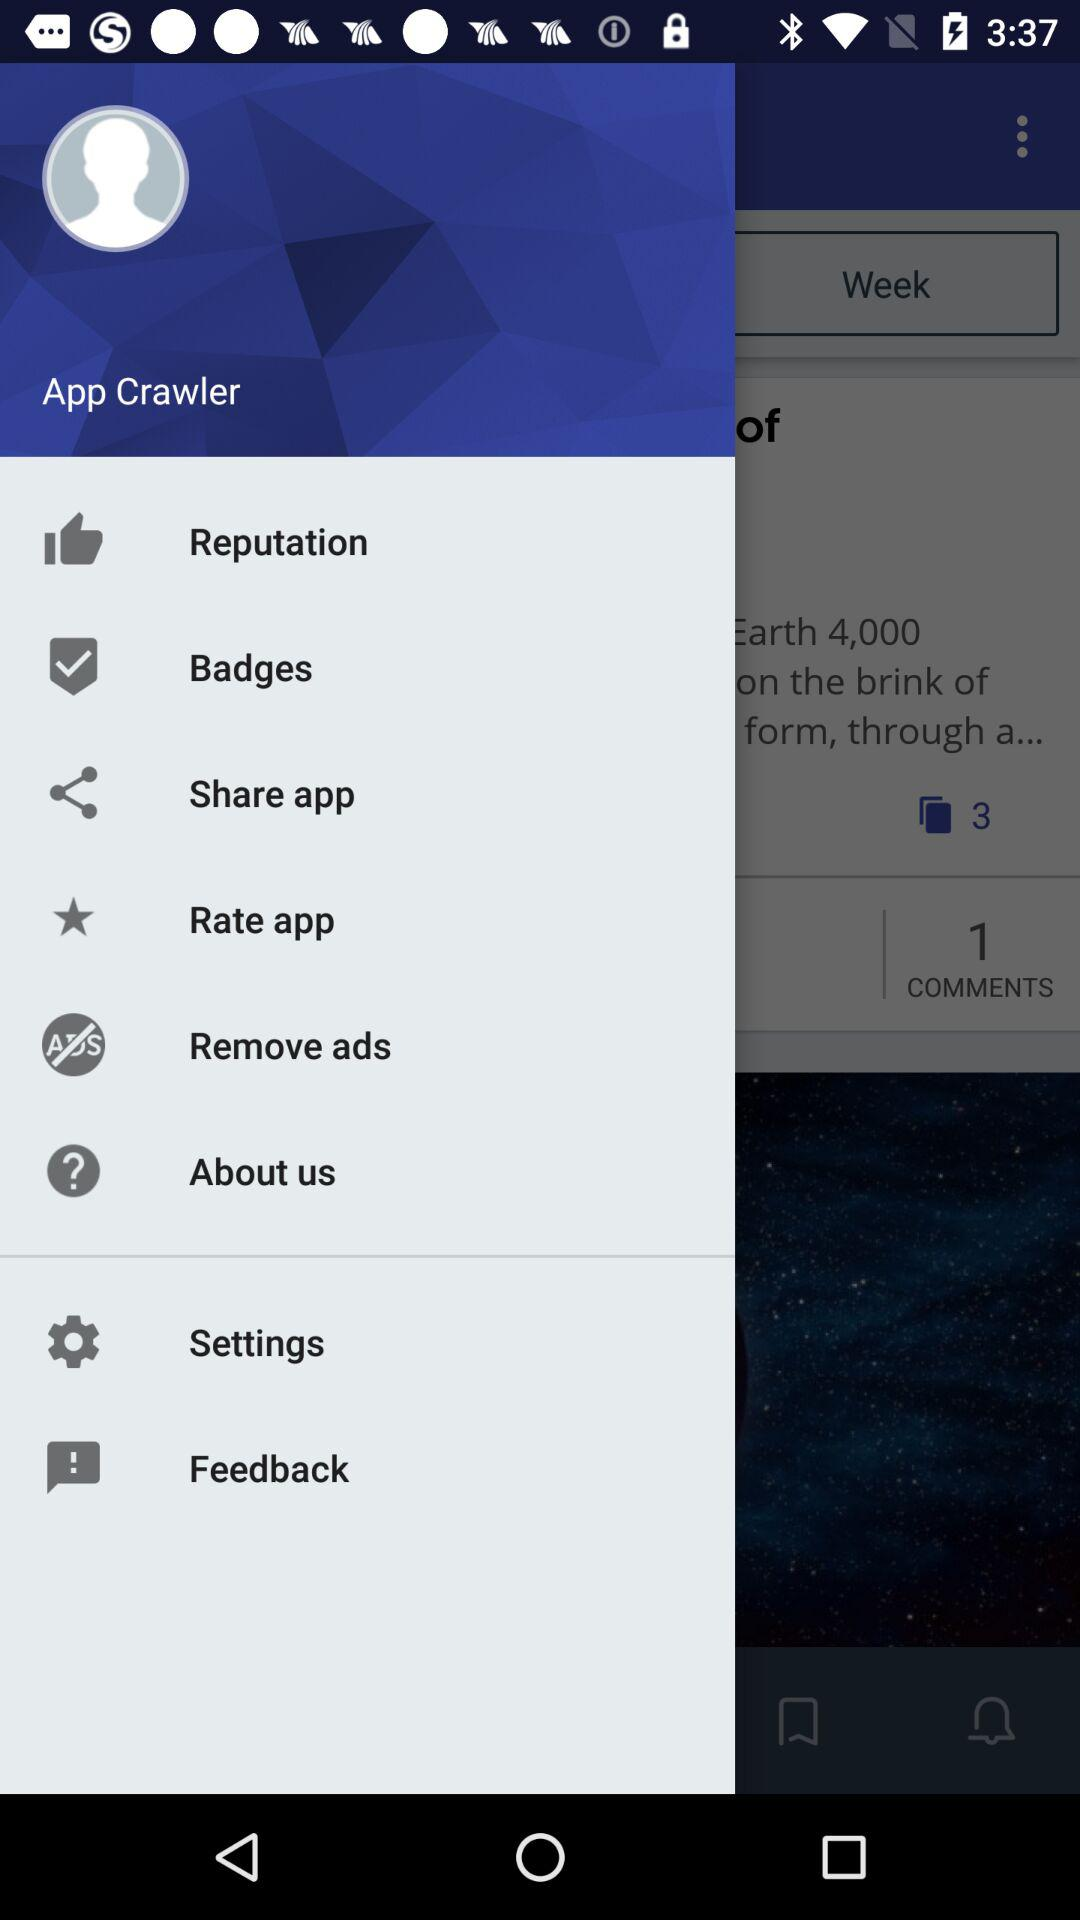What is the name of the user? The name of the user is App Crawler. 